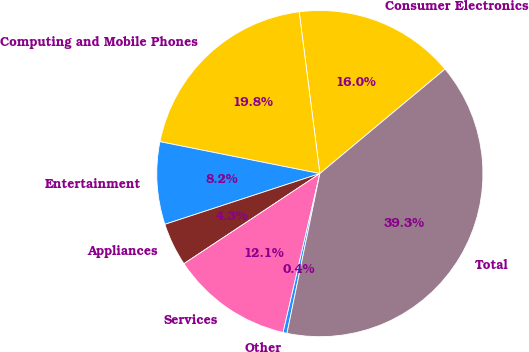Convert chart. <chart><loc_0><loc_0><loc_500><loc_500><pie_chart><fcel>Consumer Electronics<fcel>Computing and Mobile Phones<fcel>Entertainment<fcel>Appliances<fcel>Services<fcel>Other<fcel>Total<nl><fcel>15.95%<fcel>19.84%<fcel>8.17%<fcel>4.28%<fcel>12.06%<fcel>0.39%<fcel>39.29%<nl></chart> 